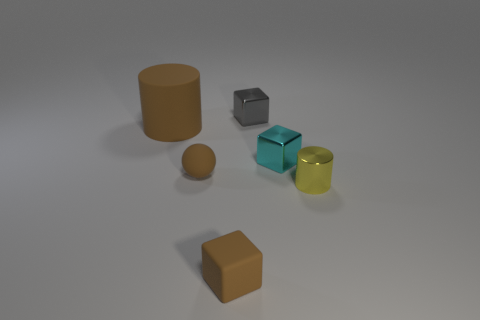There is a cylinder that is the same color as the rubber sphere; what size is it?
Provide a succinct answer. Large. Are the cylinder that is on the left side of the tiny gray metallic thing and the cube that is in front of the tiny cyan thing made of the same material?
Keep it short and to the point. Yes. What is the tiny yellow thing made of?
Offer a very short reply. Metal. What number of small yellow objects have the same material as the tiny brown cube?
Keep it short and to the point. 0. How many matte objects are blocks or large gray cubes?
Your answer should be compact. 1. Does the tiny brown rubber object on the left side of the tiny brown matte cube have the same shape as the object behind the big rubber cylinder?
Ensure brevity in your answer.  No. What is the color of the small object that is both on the left side of the small gray metallic object and behind the small cylinder?
Provide a succinct answer. Brown. Do the brown rubber object in front of the small yellow metal cylinder and the shiny object that is to the right of the cyan metallic thing have the same size?
Provide a succinct answer. Yes. How many big matte cylinders are the same color as the shiny cylinder?
Your response must be concise. 0. How many small objects are either cyan shiny cubes or gray cylinders?
Your answer should be very brief. 1. 